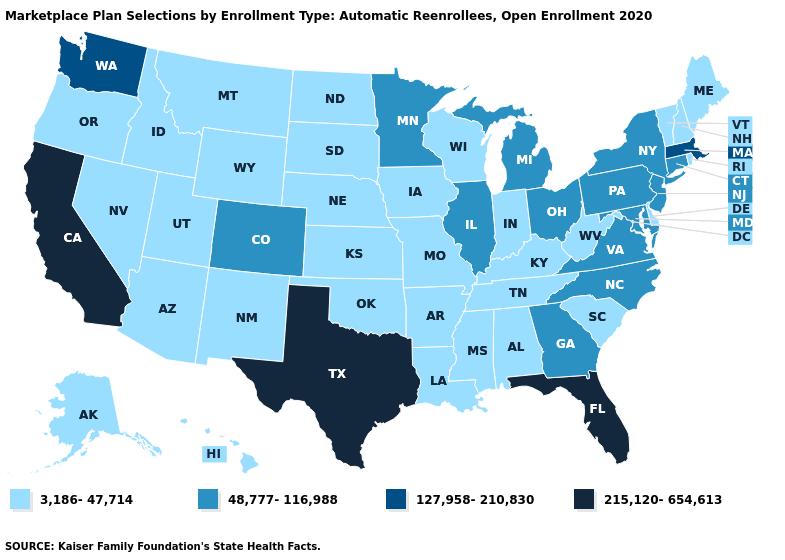How many symbols are there in the legend?
Give a very brief answer. 4. What is the lowest value in the USA?
Keep it brief. 3,186-47,714. What is the lowest value in the USA?
Concise answer only. 3,186-47,714. Name the states that have a value in the range 3,186-47,714?
Short answer required. Alabama, Alaska, Arizona, Arkansas, Delaware, Hawaii, Idaho, Indiana, Iowa, Kansas, Kentucky, Louisiana, Maine, Mississippi, Missouri, Montana, Nebraska, Nevada, New Hampshire, New Mexico, North Dakota, Oklahoma, Oregon, Rhode Island, South Carolina, South Dakota, Tennessee, Utah, Vermont, West Virginia, Wisconsin, Wyoming. Among the states that border Louisiana , which have the highest value?
Short answer required. Texas. Among the states that border Illinois , which have the highest value?
Be succinct. Indiana, Iowa, Kentucky, Missouri, Wisconsin. Name the states that have a value in the range 127,958-210,830?
Concise answer only. Massachusetts, Washington. Is the legend a continuous bar?
Give a very brief answer. No. Which states have the lowest value in the USA?
Keep it brief. Alabama, Alaska, Arizona, Arkansas, Delaware, Hawaii, Idaho, Indiana, Iowa, Kansas, Kentucky, Louisiana, Maine, Mississippi, Missouri, Montana, Nebraska, Nevada, New Hampshire, New Mexico, North Dakota, Oklahoma, Oregon, Rhode Island, South Carolina, South Dakota, Tennessee, Utah, Vermont, West Virginia, Wisconsin, Wyoming. Name the states that have a value in the range 48,777-116,988?
Give a very brief answer. Colorado, Connecticut, Georgia, Illinois, Maryland, Michigan, Minnesota, New Jersey, New York, North Carolina, Ohio, Pennsylvania, Virginia. Which states hav the highest value in the MidWest?
Write a very short answer. Illinois, Michigan, Minnesota, Ohio. Name the states that have a value in the range 127,958-210,830?
Answer briefly. Massachusetts, Washington. What is the lowest value in the Northeast?
Write a very short answer. 3,186-47,714. What is the value of Tennessee?
Quick response, please. 3,186-47,714. Does Hawaii have the lowest value in the West?
Keep it brief. Yes. 